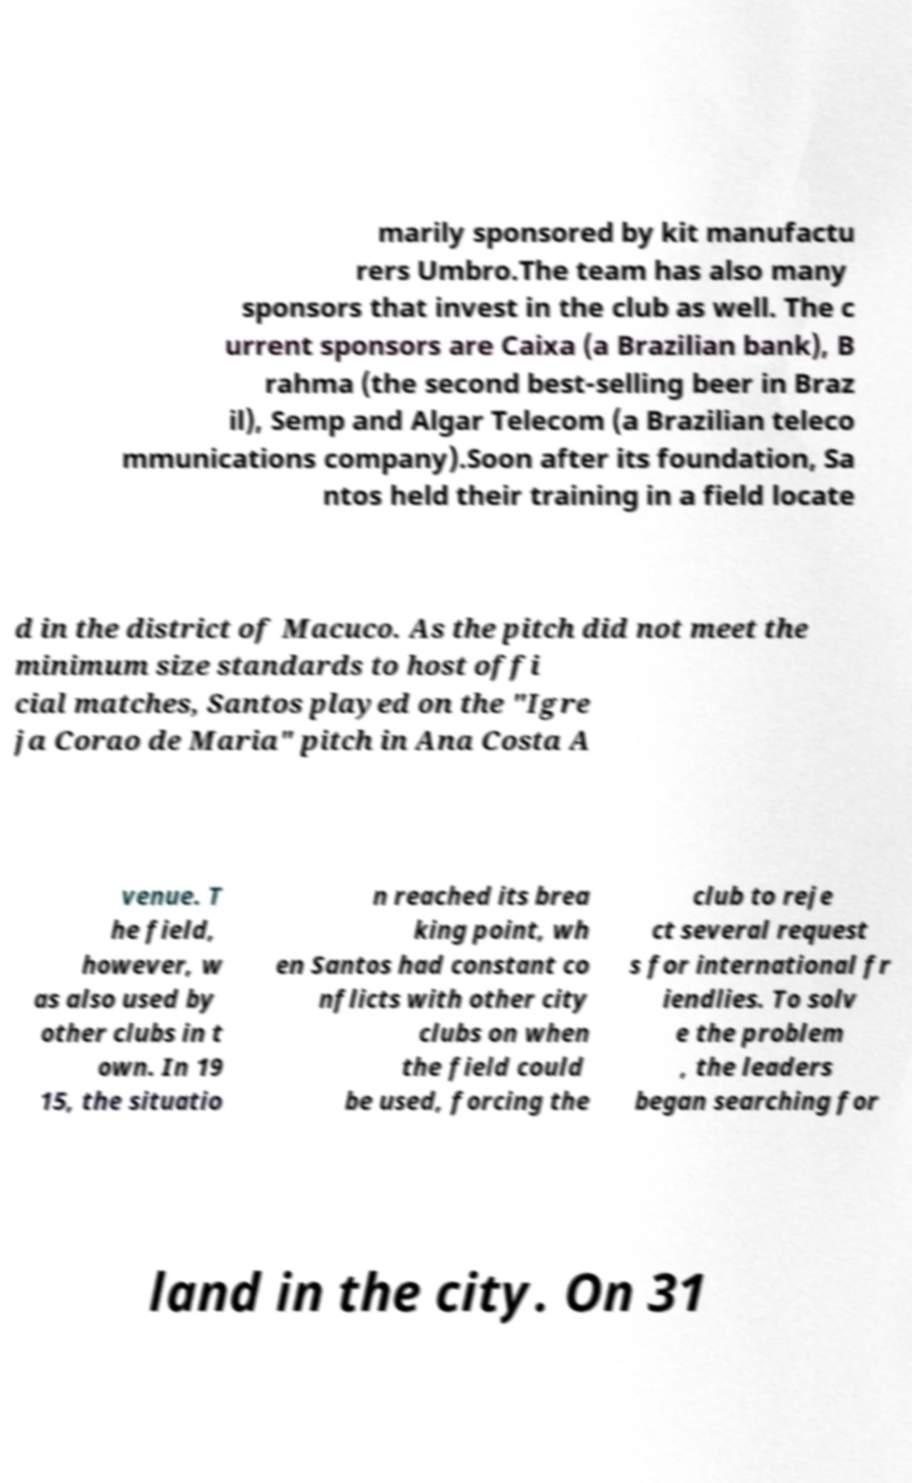I need the written content from this picture converted into text. Can you do that? marily sponsored by kit manufactu rers Umbro.The team has also many sponsors that invest in the club as well. The c urrent sponsors are Caixa (a Brazilian bank), B rahma (the second best-selling beer in Braz il), Semp and Algar Telecom (a Brazilian teleco mmunications company).Soon after its foundation, Sa ntos held their training in a field locate d in the district of Macuco. As the pitch did not meet the minimum size standards to host offi cial matches, Santos played on the "Igre ja Corao de Maria" pitch in Ana Costa A venue. T he field, however, w as also used by other clubs in t own. In 19 15, the situatio n reached its brea king point, wh en Santos had constant co nflicts with other city clubs on when the field could be used, forcing the club to reje ct several request s for international fr iendlies. To solv e the problem , the leaders began searching for land in the city. On 31 